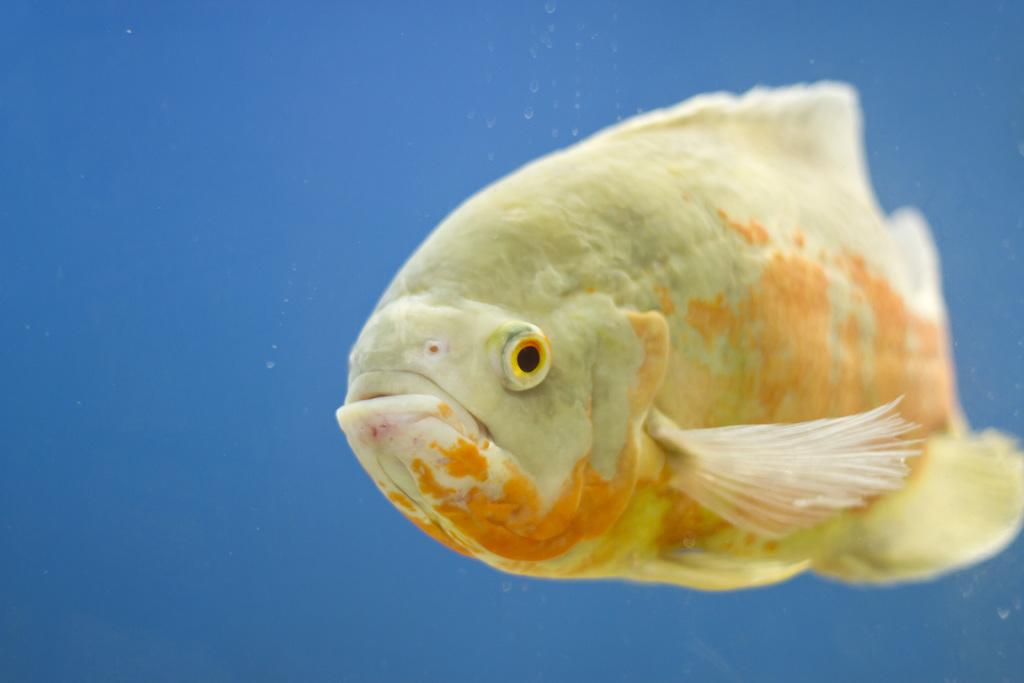What is the main subject of the image? There is a fish in the image. What color is the background of the image? The background of the image is blue. What type of rule can be seen governing the behavior of the fish in the image? There is no rule governing the behavior of the fish in the image, as it is a static image and not a video or animation. 